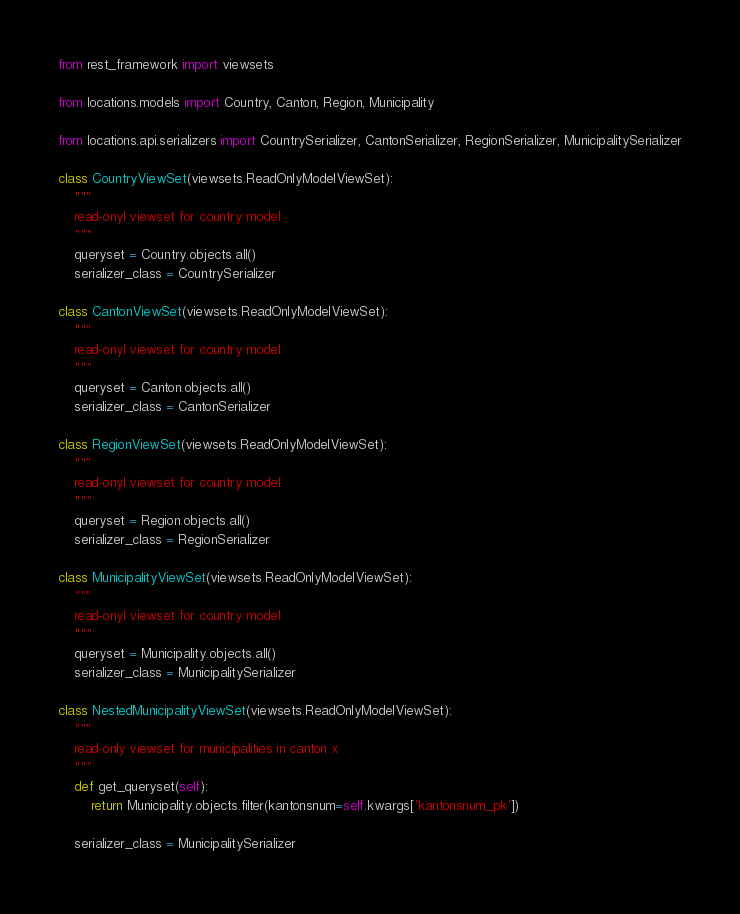Convert code to text. <code><loc_0><loc_0><loc_500><loc_500><_Python_>from rest_framework import viewsets

from locations.models import Country, Canton, Region, Municipality

from locations.api.serializers import CountrySerializer, CantonSerializer, RegionSerializer, MunicipalitySerializer

class CountryViewSet(viewsets.ReadOnlyModelViewSet):
    """
    read-onyl viewset for country model
    """
    queryset = Country.objects.all()
    serializer_class = CountrySerializer

class CantonViewSet(viewsets.ReadOnlyModelViewSet):
    """
    read-onyl viewset for country model
    """
    queryset = Canton.objects.all()
    serializer_class = CantonSerializer

class RegionViewSet(viewsets.ReadOnlyModelViewSet):
    """
    read-onyl viewset for country model
    """
    queryset = Region.objects.all()
    serializer_class = RegionSerializer

class MunicipalityViewSet(viewsets.ReadOnlyModelViewSet):
    """
    read-onyl viewset for country model
    """
    queryset = Municipality.objects.all()
    serializer_class = MunicipalitySerializer

class NestedMunicipalityViewSet(viewsets.ReadOnlyModelViewSet):
    """
    read-only viewset for municipalities in canton x
    """
    def get_queryset(self):
        return Municipality.objects.filter(kantonsnum=self.kwargs['kantonsnum_pk'])

    serializer_class = MunicipalitySerializer</code> 